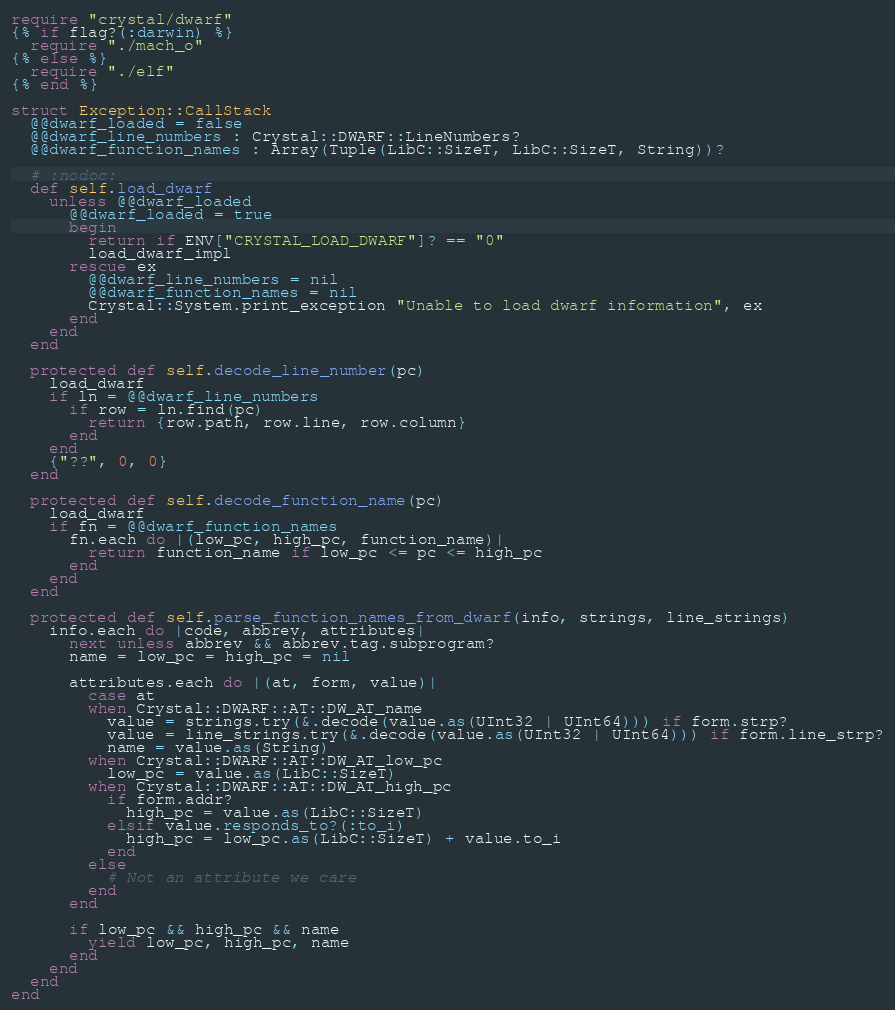Convert code to text. <code><loc_0><loc_0><loc_500><loc_500><_Crystal_>require "crystal/dwarf"
{% if flag?(:darwin) %}
  require "./mach_o"
{% else %}
  require "./elf"
{% end %}

struct Exception::CallStack
  @@dwarf_loaded = false
  @@dwarf_line_numbers : Crystal::DWARF::LineNumbers?
  @@dwarf_function_names : Array(Tuple(LibC::SizeT, LibC::SizeT, String))?

  # :nodoc:
  def self.load_dwarf
    unless @@dwarf_loaded
      @@dwarf_loaded = true
      begin
        return if ENV["CRYSTAL_LOAD_DWARF"]? == "0"
        load_dwarf_impl
      rescue ex
        @@dwarf_line_numbers = nil
        @@dwarf_function_names = nil
        Crystal::System.print_exception "Unable to load dwarf information", ex
      end
    end
  end

  protected def self.decode_line_number(pc)
    load_dwarf
    if ln = @@dwarf_line_numbers
      if row = ln.find(pc)
        return {row.path, row.line, row.column}
      end
    end
    {"??", 0, 0}
  end

  protected def self.decode_function_name(pc)
    load_dwarf
    if fn = @@dwarf_function_names
      fn.each do |(low_pc, high_pc, function_name)|
        return function_name if low_pc <= pc <= high_pc
      end
    end
  end

  protected def self.parse_function_names_from_dwarf(info, strings, line_strings)
    info.each do |code, abbrev, attributes|
      next unless abbrev && abbrev.tag.subprogram?
      name = low_pc = high_pc = nil

      attributes.each do |(at, form, value)|
        case at
        when Crystal::DWARF::AT::DW_AT_name
          value = strings.try(&.decode(value.as(UInt32 | UInt64))) if form.strp?
          value = line_strings.try(&.decode(value.as(UInt32 | UInt64))) if form.line_strp?
          name = value.as(String)
        when Crystal::DWARF::AT::DW_AT_low_pc
          low_pc = value.as(LibC::SizeT)
        when Crystal::DWARF::AT::DW_AT_high_pc
          if form.addr?
            high_pc = value.as(LibC::SizeT)
          elsif value.responds_to?(:to_i)
            high_pc = low_pc.as(LibC::SizeT) + value.to_i
          end
        else
          # Not an attribute we care
        end
      end

      if low_pc && high_pc && name
        yield low_pc, high_pc, name
      end
    end
  end
end
</code> 